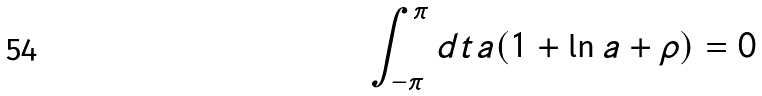Convert formula to latex. <formula><loc_0><loc_0><loc_500><loc_500>\int _ { - \pi } ^ { \pi } d t a ( 1 + \ln a + \rho ) = 0</formula> 